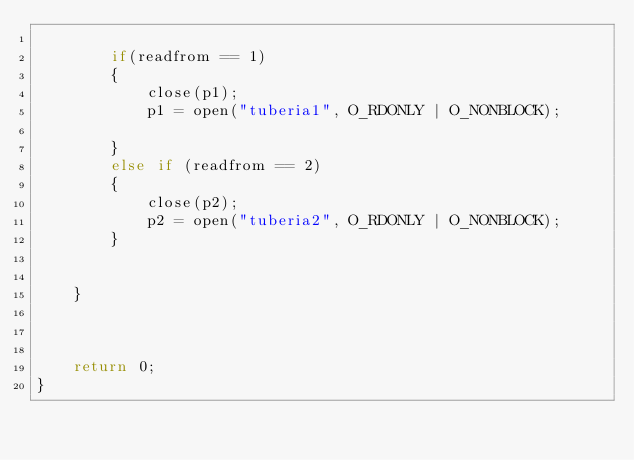<code> <loc_0><loc_0><loc_500><loc_500><_C_>
        if(readfrom == 1)
        {
            close(p1);
            p1 = open("tuberia1", O_RDONLY | O_NONBLOCK);

        }
        else if (readfrom == 2)
        {
            close(p2);
            p2 = open("tuberia2", O_RDONLY | O_NONBLOCK);
        }


    }



    return 0;
}</code> 